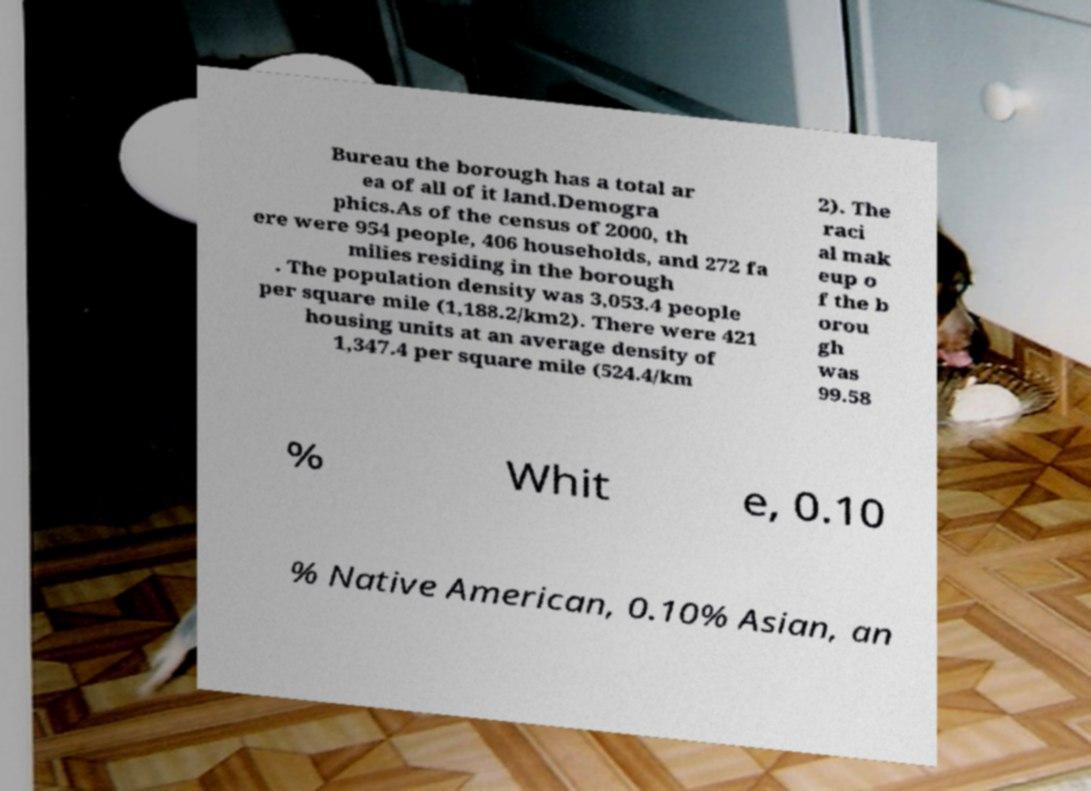Please identify and transcribe the text found in this image. Bureau the borough has a total ar ea of all of it land.Demogra phics.As of the census of 2000, th ere were 954 people, 406 households, and 272 fa milies residing in the borough . The population density was 3,053.4 people per square mile (1,188.2/km2). There were 421 housing units at an average density of 1,347.4 per square mile (524.4/km 2). The raci al mak eup o f the b orou gh was 99.58 % Whit e, 0.10 % Native American, 0.10% Asian, an 